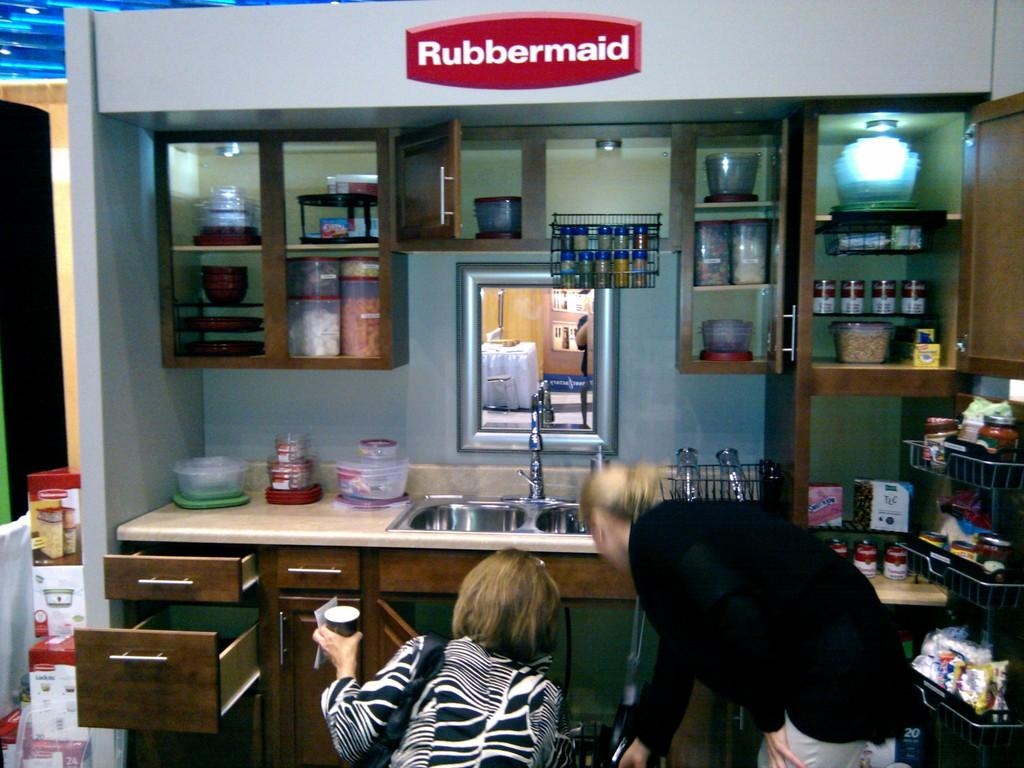<image>
Give a short and clear explanation of the subsequent image. 2 women are in front of a kitchen display by Rubbermaid. 